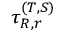<formula> <loc_0><loc_0><loc_500><loc_500>\tau _ { R , r } ^ { ( T , S ) }</formula> 